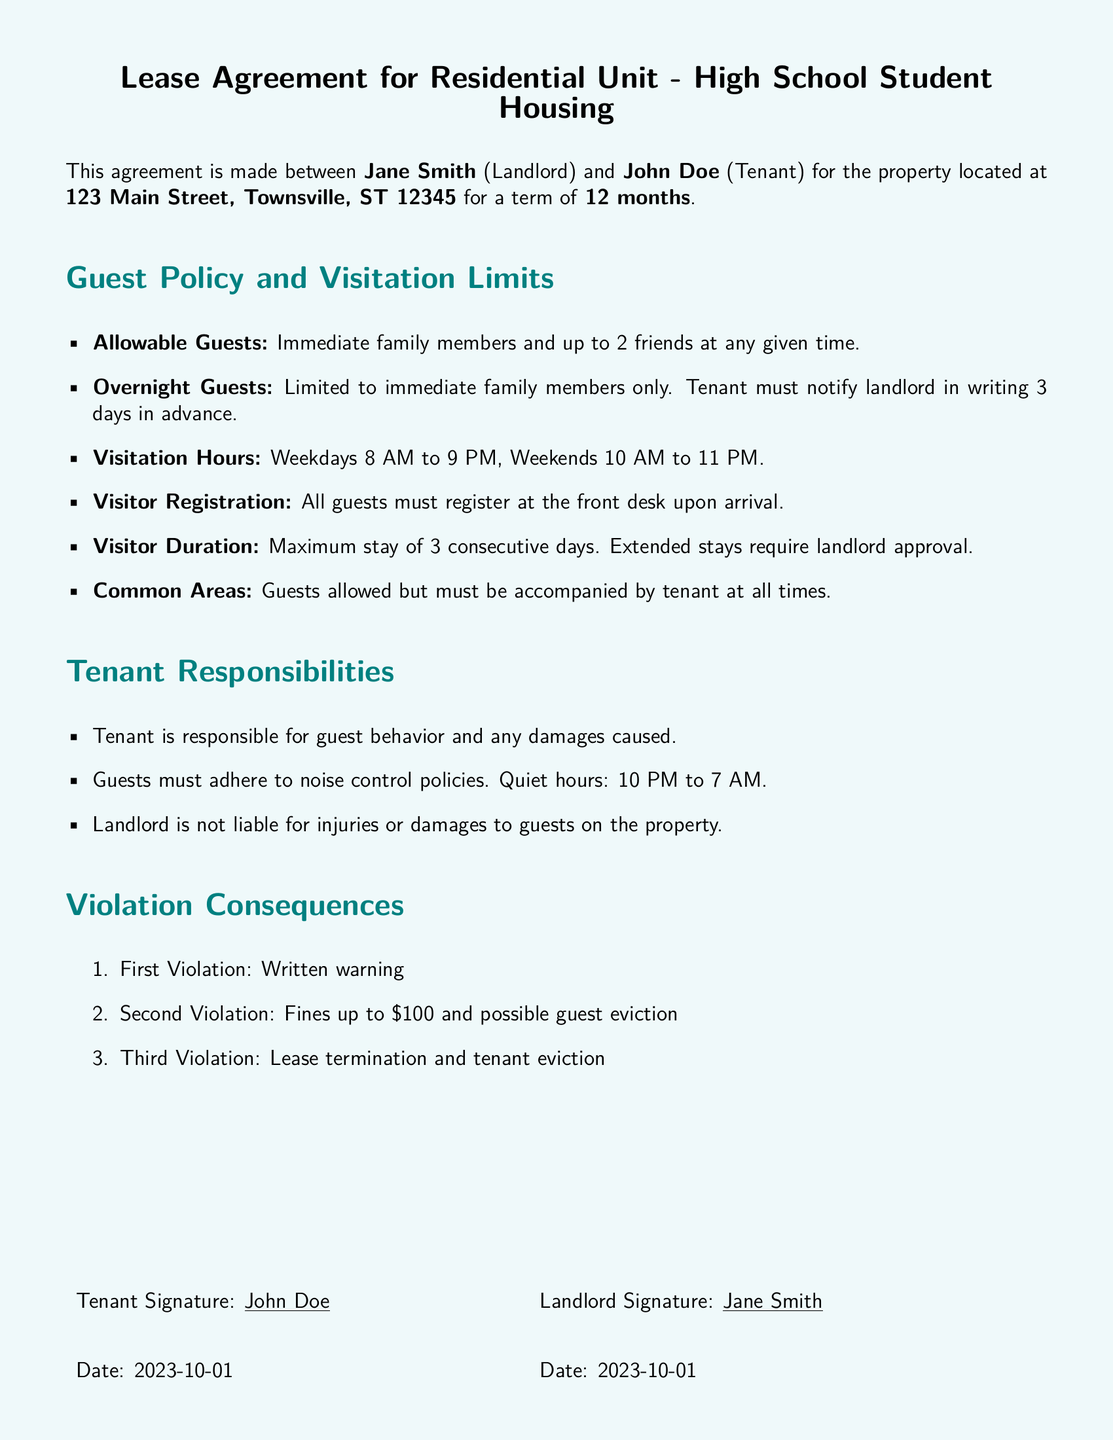What is the name of the landlord? The landlord is named in the document as the person who made the lease agreement, which is Jane Smith.
Answer: Jane Smith How many friends can the tenant have as guests? The document states that the tenant can have up to two friends at any given time as guests.
Answer: 2 friends What is the notice period for overnight guests? The tenant must notify the landlord in writing three days in advance for overnight guests.
Answer: 3 days What are the weekday visitation hours? The visitation hours on weekdays are outlined in the document, specifying the time range from 8 AM to 9 PM.
Answer: 8 AM to 9 PM What is the maximum duration for a guest's stay? The document states that the maximum stay for a guest is three consecutive days.
Answer: 3 consecutive days Who is responsible for guest behavior? The document specifies that the tenant is responsible for the behavior of their guests at the property.
Answer: Tenant What are the quiet hours mentioned in the document? The quiet hours, as per the document, are from 10 PM to 7 AM.
Answer: 10 PM to 7 AM What happens on the third violation? The consequences for a third violation include lease termination and tenant eviction as stated in the document.
Answer: Lease termination and tenant eviction 